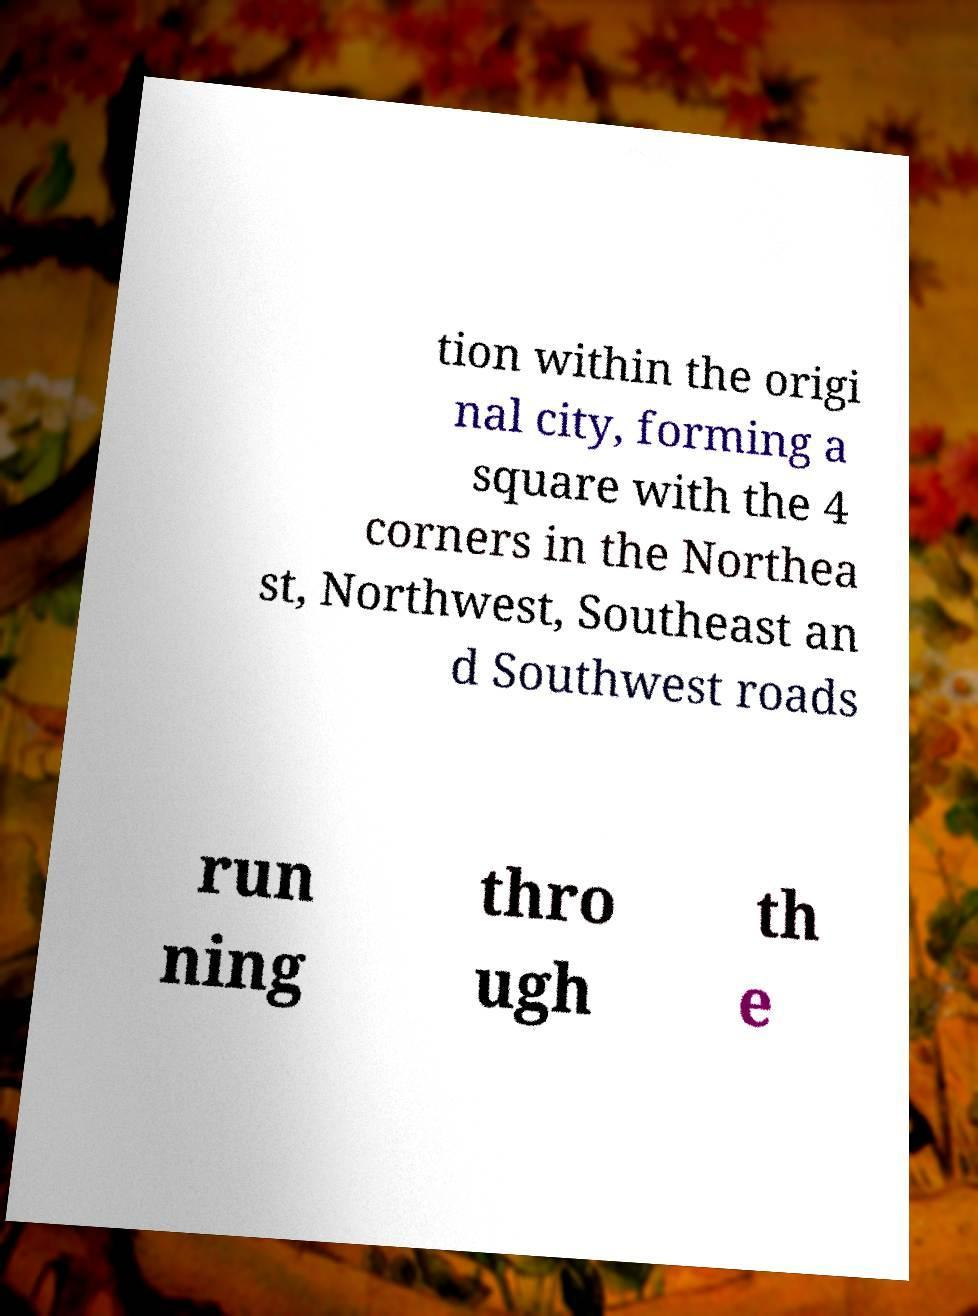Could you extract and type out the text from this image? tion within the origi nal city, forming a square with the 4 corners in the Northea st, Northwest, Southeast an d Southwest roads run ning thro ugh th e 